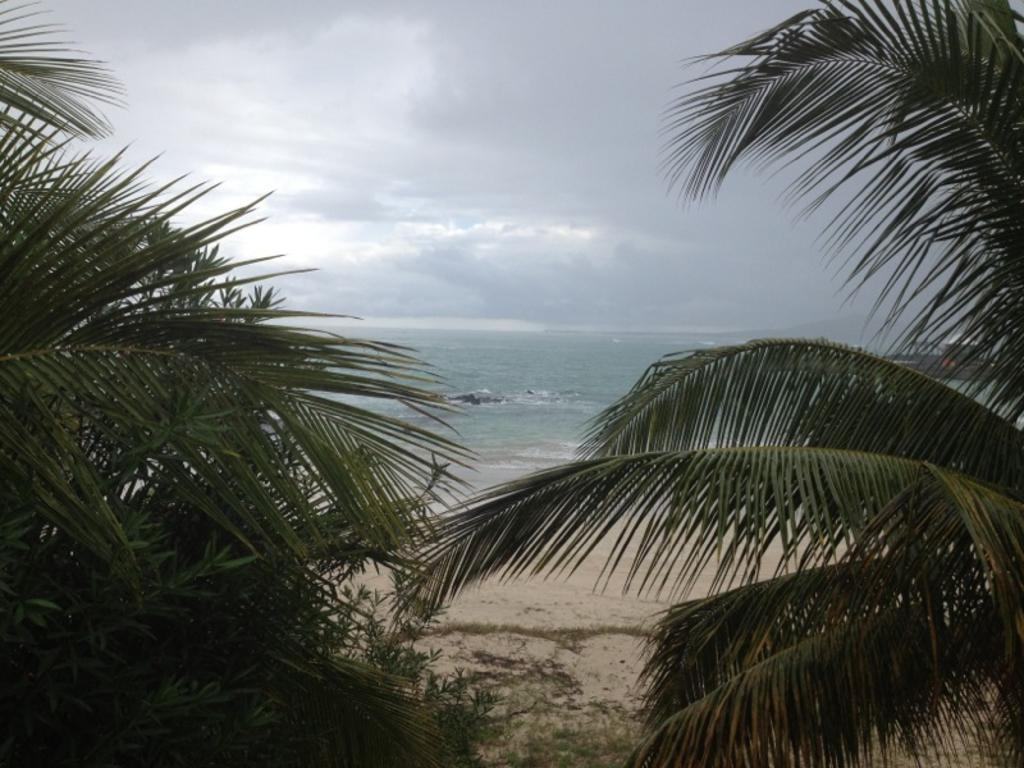What type of natural environment is depicted in the image? There is a sea in the image. What type of vegetation can be seen in the image? There are trees and grass visible in the image. What is located in the water in the image? There is an object in the water. How would you describe the weather in the image? The sky is cloudy in the image. What reason does the kettle give for leaving the image? There is no kettle present in the image, so it cannot provide any reason for leaving. 